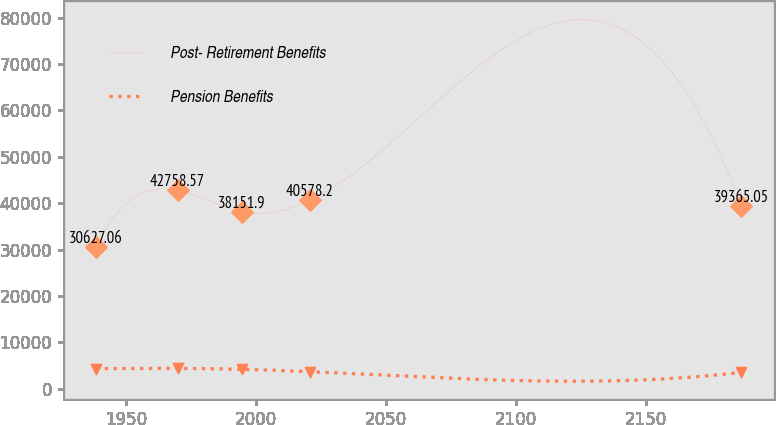<chart> <loc_0><loc_0><loc_500><loc_500><line_chart><ecel><fcel>Post- Retirement Benefits<fcel>Pension Benefits<nl><fcel>1938.4<fcel>30627.1<fcel>4303.62<nl><fcel>1969.87<fcel>42758.6<fcel>4381.01<nl><fcel>1994.72<fcel>38151.9<fcel>4175.67<nl><fcel>2020.71<fcel>40578.2<fcel>3668.81<nl><fcel>2186.93<fcel>39365.1<fcel>3549.71<nl></chart> 